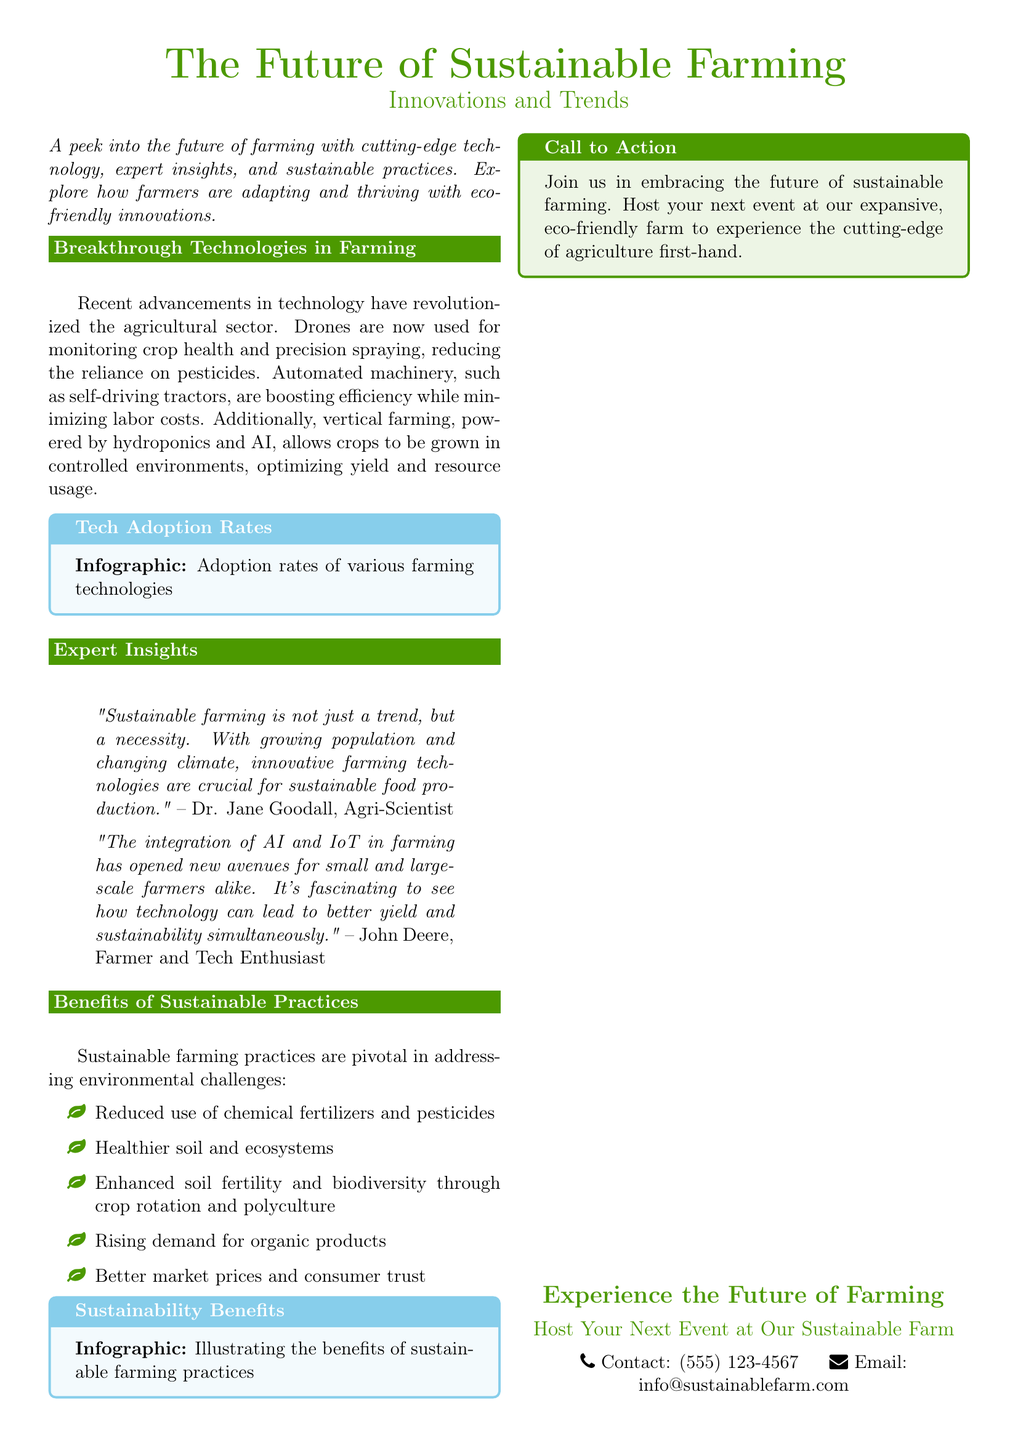What is the main theme of the document? The main theme describes innovative farming technology and sustainable practices.
Answer: The Future of Sustainable Farming Who is quoted as stating that sustainable farming is a necessity? The document includes a quote from an agri-scientist emphasizing the need for sustainable farming.
Answer: Dr. Jane Goodall What technology is used for monitoring crop health mentioned in the document? The document lists various technologies, including drones, used for farming innovations.
Answer: Drones What is one benefit of sustainable farming practices noted in the document? The document mentions several benefits, such as healthier soil and ecosystems.
Answer: Healthier soil and ecosystems What is the contact phone number provided in the document? The document includes a section at the end with contact details, including a phone number.
Answer: (555) 123-4567 What type of event can be hosted at the farm according to the document? The document encourages readers to host events related to eco-friendly practices at the farm.
Answer: Unique and unconventional events According to the document, what has increased demand for organic products attributed to? The document outlines trends in sustainable farming and the market response to these practices.
Answer: Rising demand for organic products What color is used for the section titles in the document? The section titles are indicated in a specific color throughout the document.
Answer: Earth green 